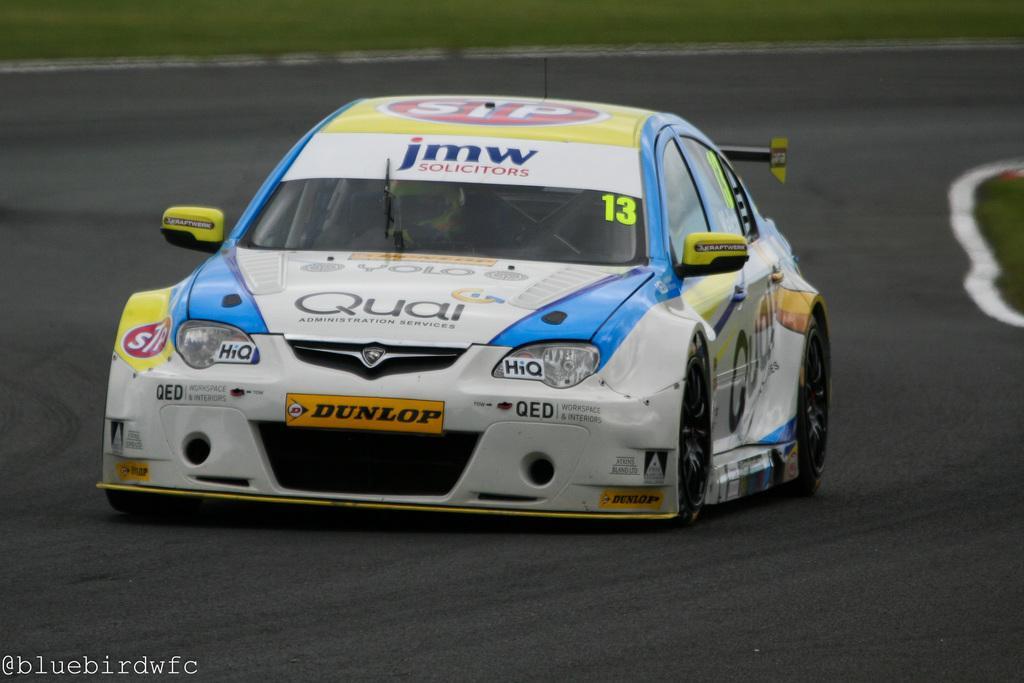Please provide a concise description of this image. In this image there is a car on the road. 